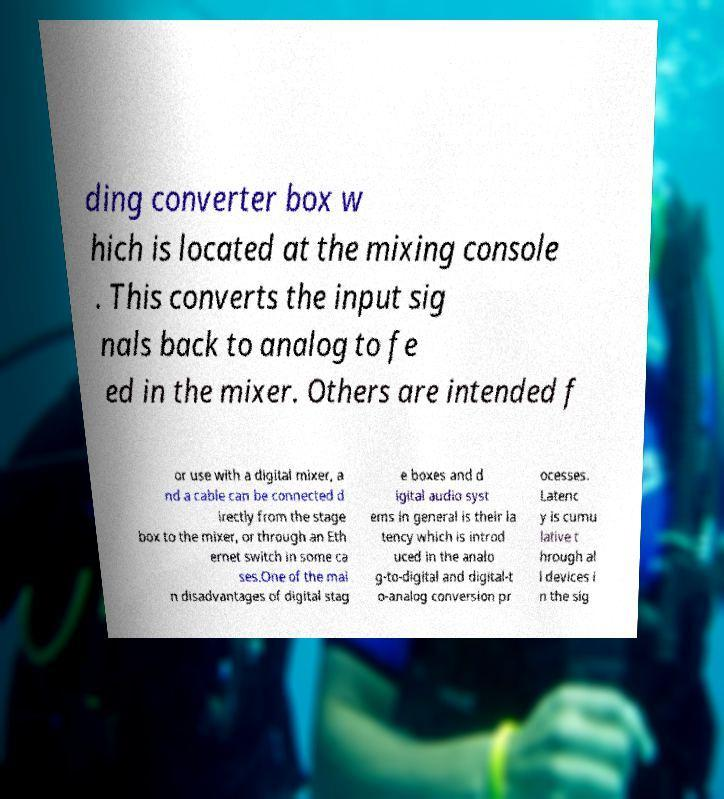Could you extract and type out the text from this image? ding converter box w hich is located at the mixing console . This converts the input sig nals back to analog to fe ed in the mixer. Others are intended f or use with a digital mixer, a nd a cable can be connected d irectly from the stage box to the mixer, or through an Eth ernet switch in some ca ses.One of the mai n disadvantages of digital stag e boxes and d igital audio syst ems in general is their la tency which is introd uced in the analo g-to-digital and digital-t o-analog conversion pr ocesses. Latenc y is cumu lative t hrough al l devices i n the sig 